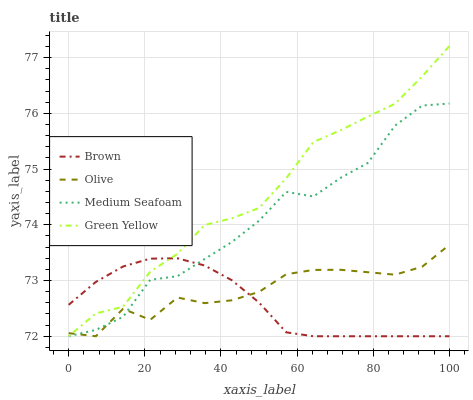Does Brown have the minimum area under the curve?
Answer yes or no. Yes. Does Green Yellow have the maximum area under the curve?
Answer yes or no. Yes. Does Green Yellow have the minimum area under the curve?
Answer yes or no. No. Does Brown have the maximum area under the curve?
Answer yes or no. No. Is Brown the smoothest?
Answer yes or no. Yes. Is Medium Seafoam the roughest?
Answer yes or no. Yes. Is Green Yellow the smoothest?
Answer yes or no. No. Is Green Yellow the roughest?
Answer yes or no. No. Does Olive have the lowest value?
Answer yes or no. Yes. Does Green Yellow have the highest value?
Answer yes or no. Yes. Does Brown have the highest value?
Answer yes or no. No. Does Olive intersect Medium Seafoam?
Answer yes or no. Yes. Is Olive less than Medium Seafoam?
Answer yes or no. No. Is Olive greater than Medium Seafoam?
Answer yes or no. No. 